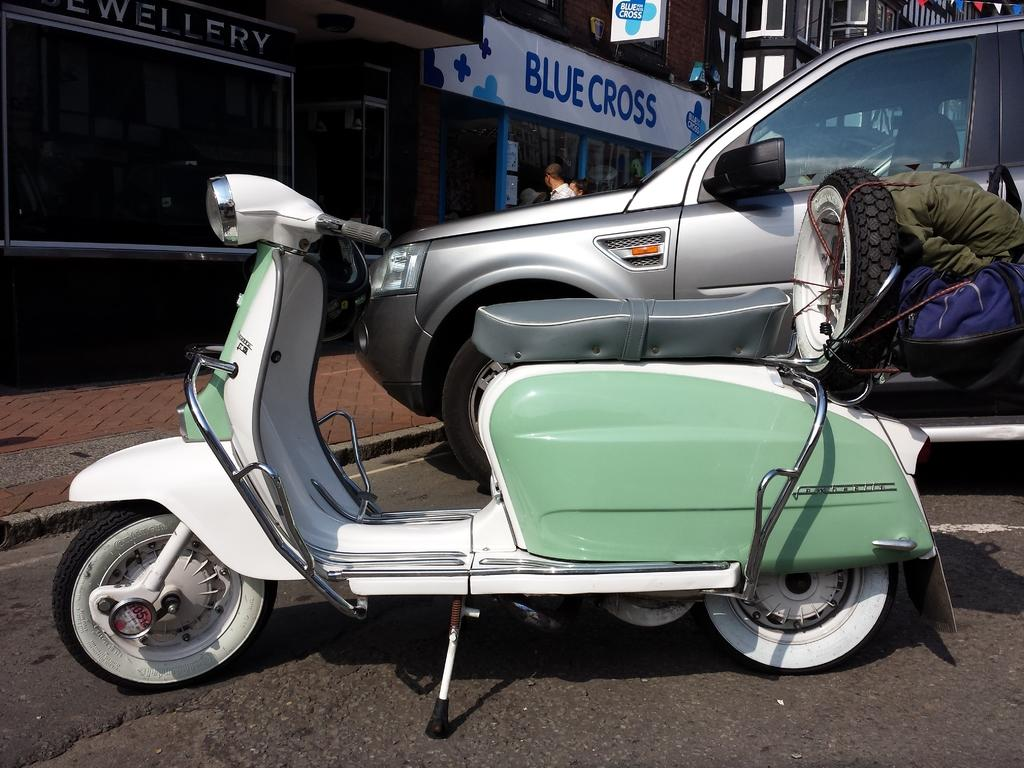What type of vehicle is on the road in the image? There is a bike and a car on the road in the image. What else can be seen on the road besides the bike and car? There are no other objects visible on the road in the image. What can be seen in the background of the image? There are buildings and boards in the background of the image. How many people are visible in the background? There are two persons in the background of the image. What type of crowd can be seen gathering around the tub in the image? There is no crowd or tub present in the image. 